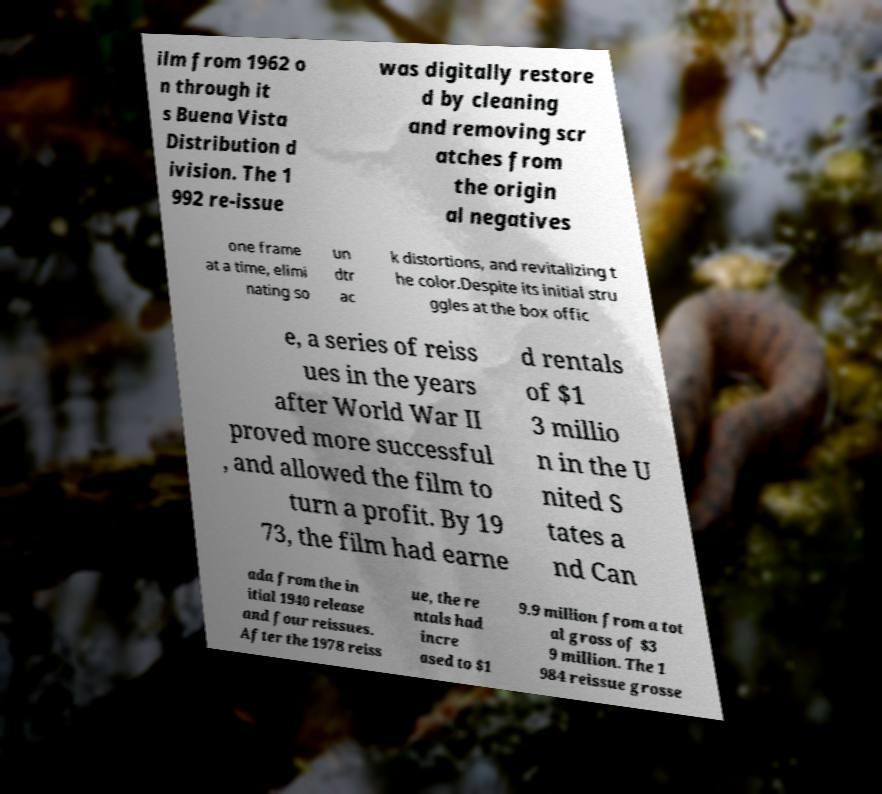There's text embedded in this image that I need extracted. Can you transcribe it verbatim? ilm from 1962 o n through it s Buena Vista Distribution d ivision. The 1 992 re-issue was digitally restore d by cleaning and removing scr atches from the origin al negatives one frame at a time, elimi nating so un dtr ac k distortions, and revitalizing t he color.Despite its initial stru ggles at the box offic e, a series of reiss ues in the years after World War II proved more successful , and allowed the film to turn a profit. By 19 73, the film had earne d rentals of $1 3 millio n in the U nited S tates a nd Can ada from the in itial 1940 release and four reissues. After the 1978 reiss ue, the re ntals had incre ased to $1 9.9 million from a tot al gross of $3 9 million. The 1 984 reissue grosse 